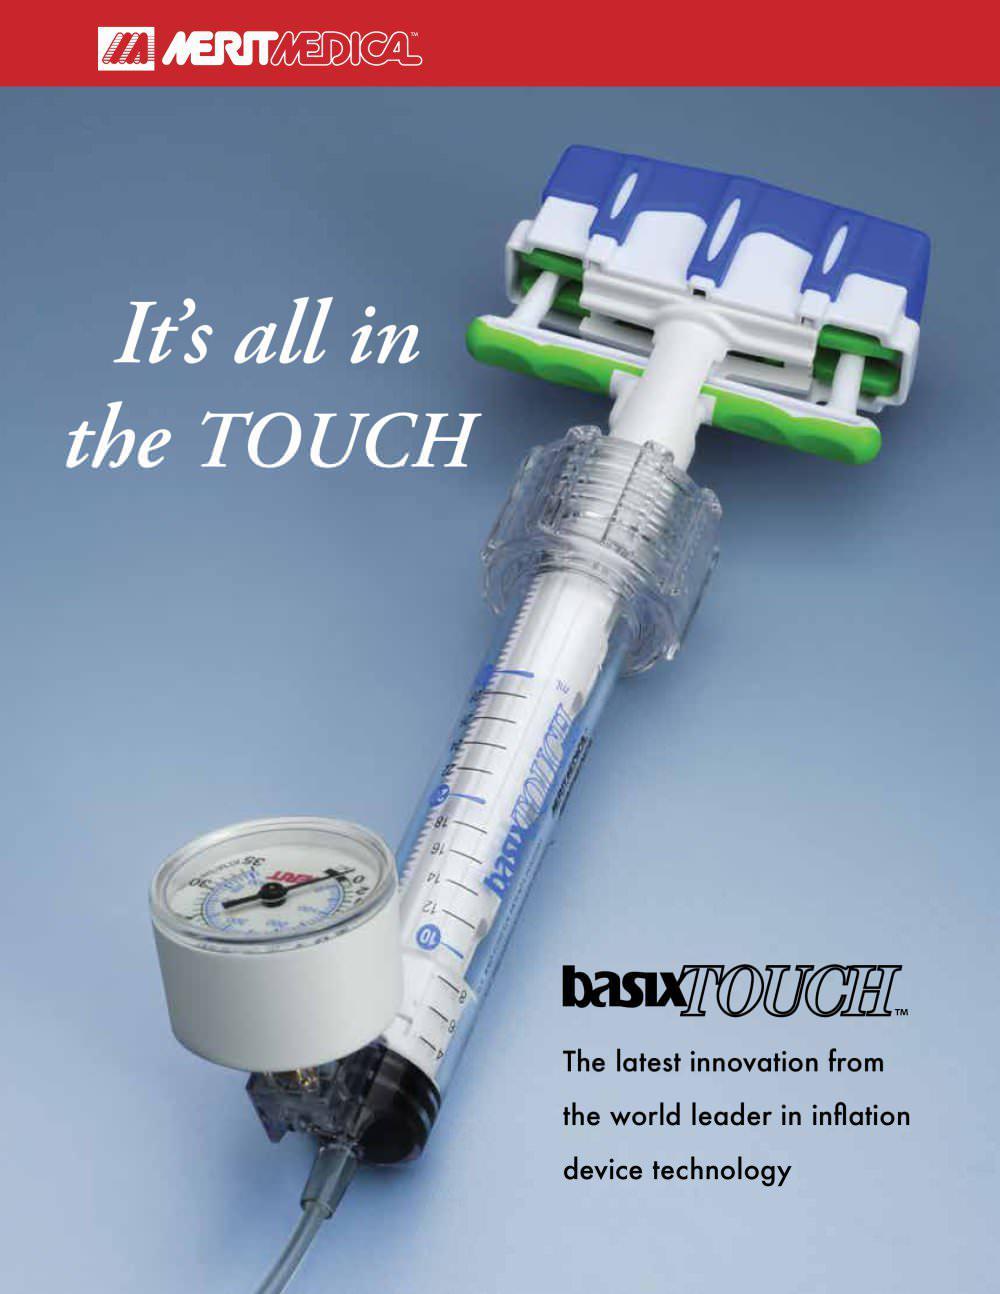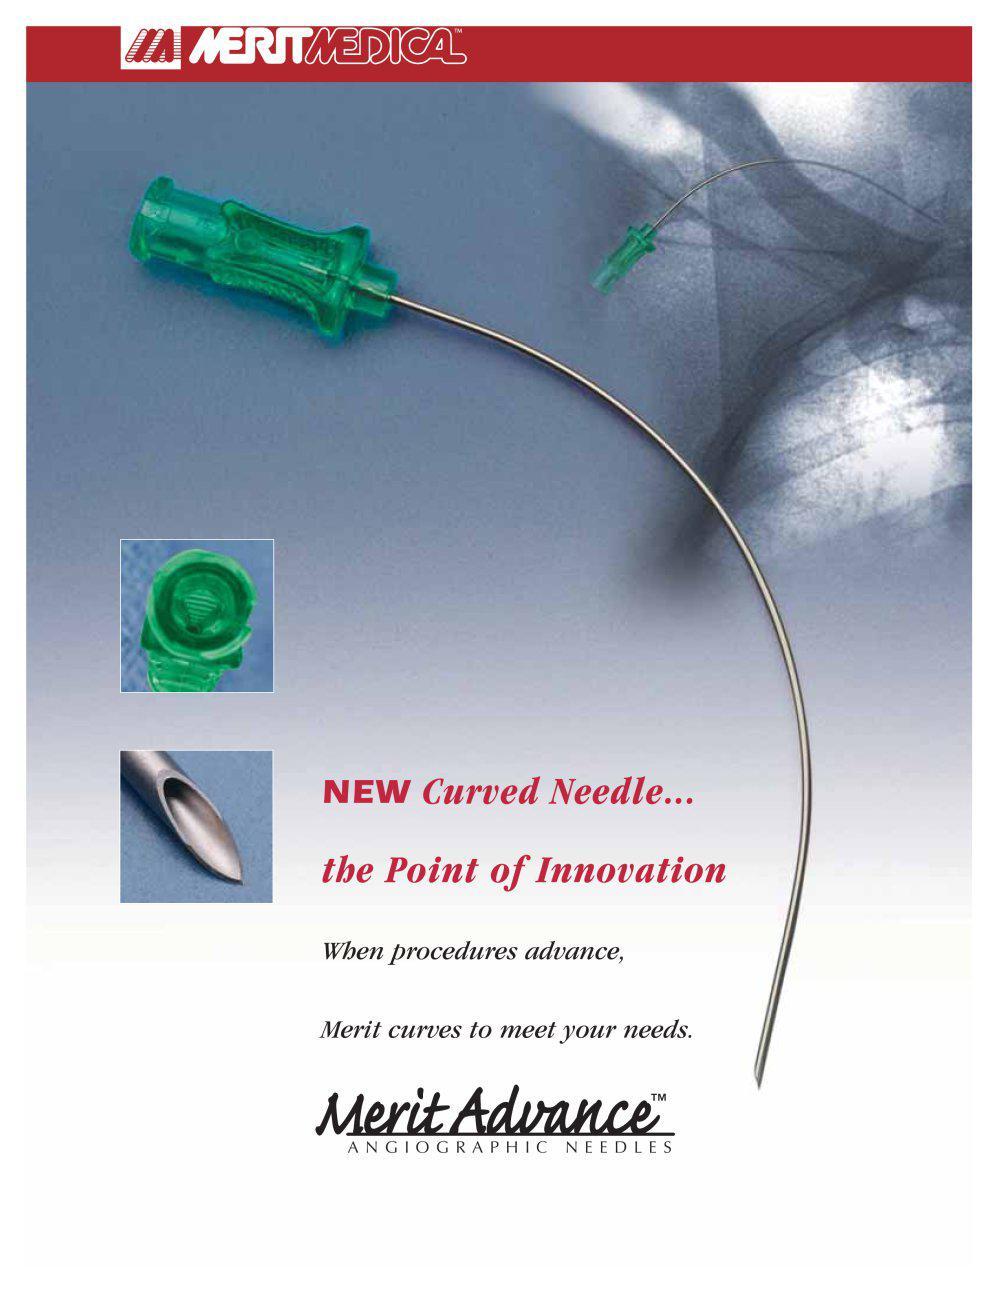The first image is the image on the left, the second image is the image on the right. Given the left and right images, does the statement "At least 1 device has a red stripe above it." hold true? Answer yes or no. Yes. 